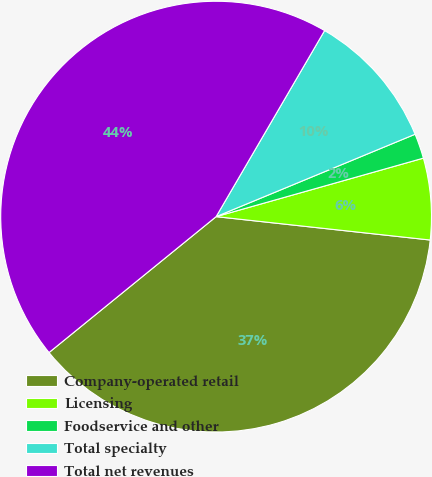Convert chart. <chart><loc_0><loc_0><loc_500><loc_500><pie_chart><fcel>Company-operated retail<fcel>Licensing<fcel>Foodservice and other<fcel>Total specialty<fcel>Total net revenues<nl><fcel>37.4%<fcel>6.11%<fcel>1.87%<fcel>10.35%<fcel>44.27%<nl></chart> 